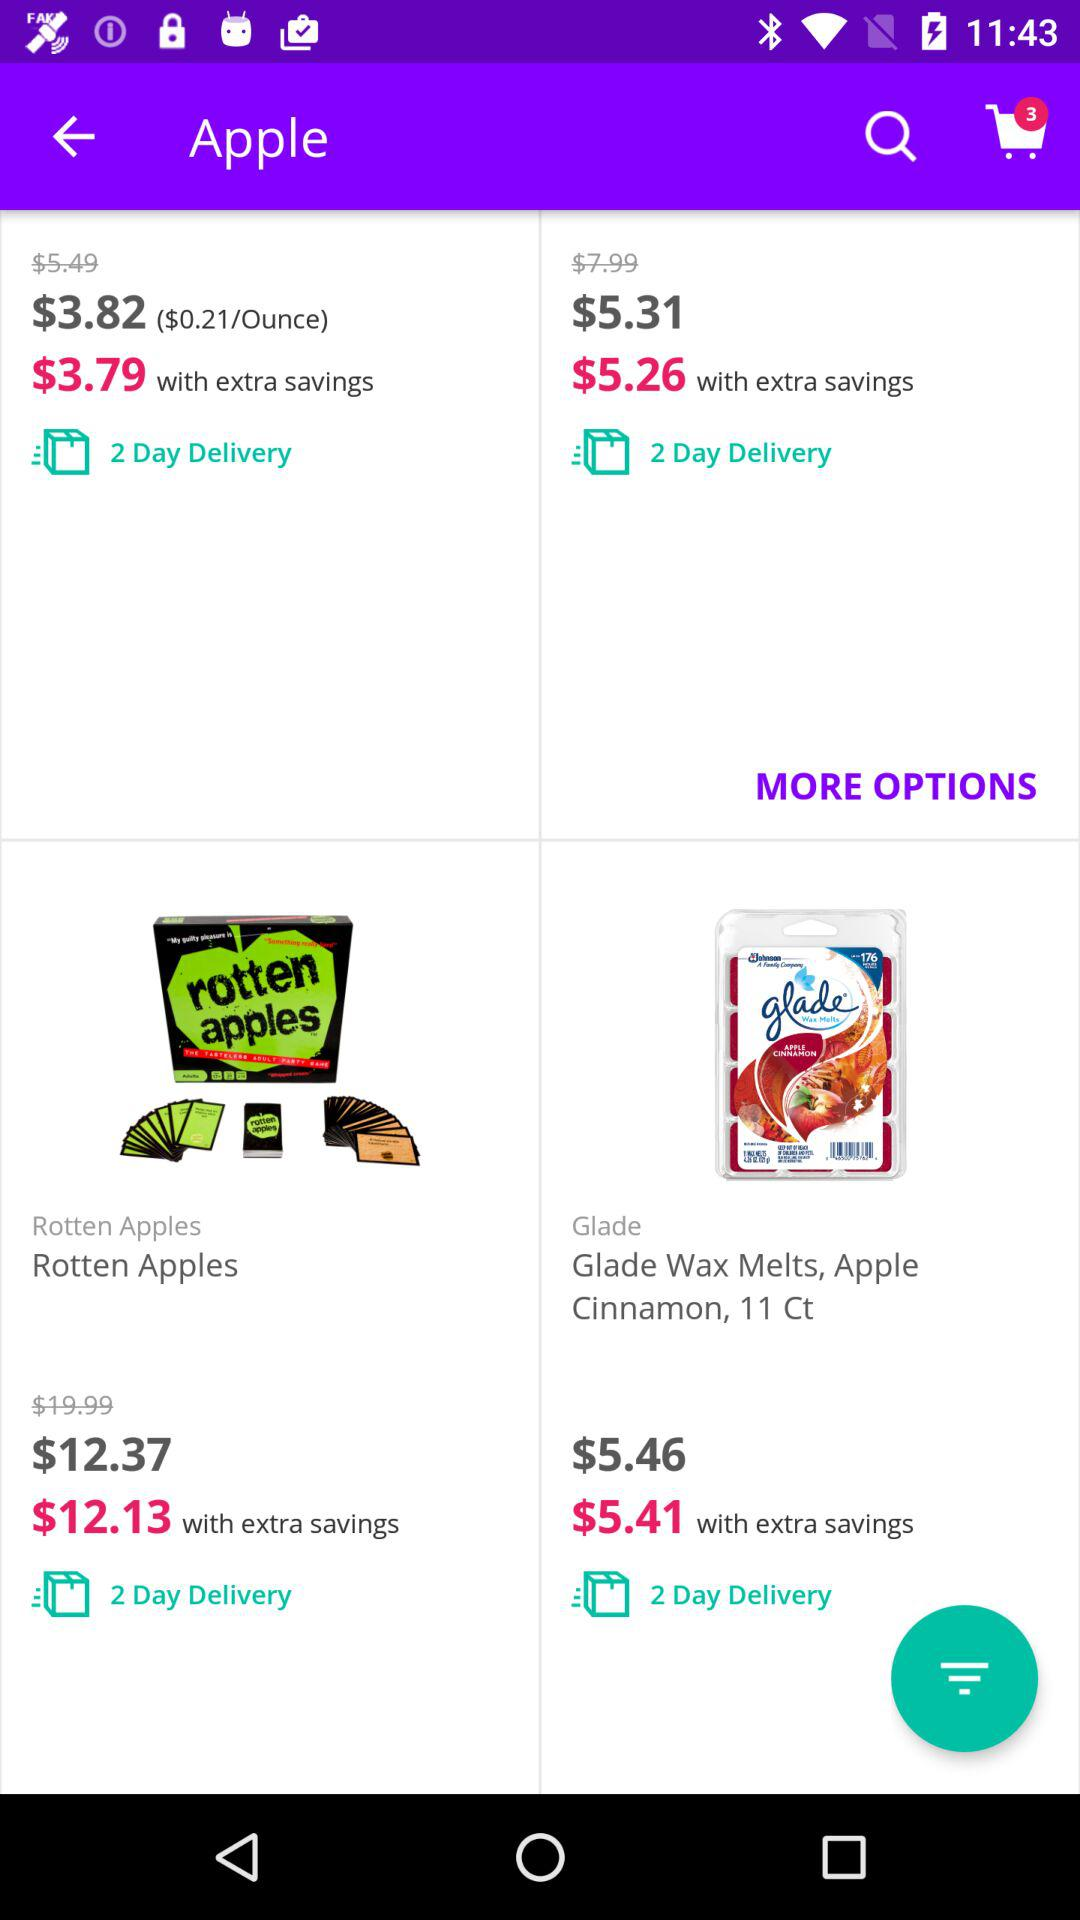Which item is cheaper, Rotten Apples or Glade Wax Melts, Apple Cinnamon?
Answer the question using a single word or phrase. Glade Wax Melts, Apple Cinnamon 